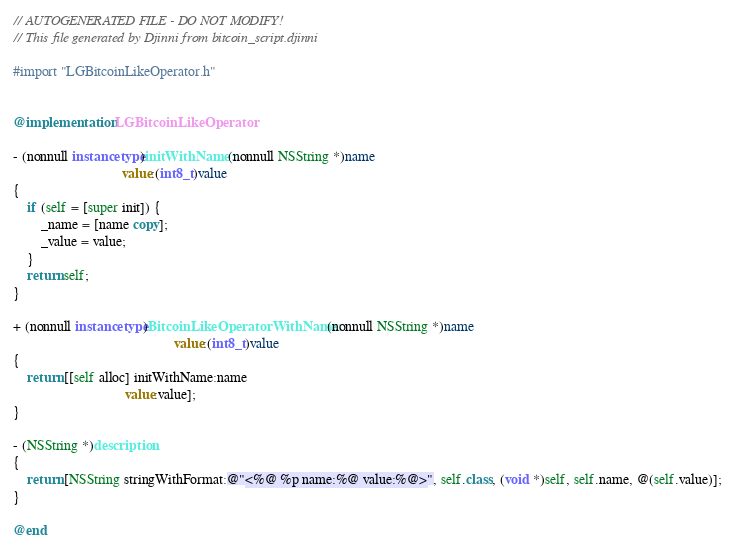<code> <loc_0><loc_0><loc_500><loc_500><_ObjectiveC_>// AUTOGENERATED FILE - DO NOT MODIFY!
// This file generated by Djinni from bitcoin_script.djinni

#import "LGBitcoinLikeOperator.h"


@implementation LGBitcoinLikeOperator

- (nonnull instancetype)initWithName:(nonnull NSString *)name
                               value:(int8_t)value
{
    if (self = [super init]) {
        _name = [name copy];
        _value = value;
    }
    return self;
}

+ (nonnull instancetype)BitcoinLikeOperatorWithName:(nonnull NSString *)name
                                              value:(int8_t)value
{
    return [[self alloc] initWithName:name
                                value:value];
}

- (NSString *)description
{
    return [NSString stringWithFormat:@"<%@ %p name:%@ value:%@>", self.class, (void *)self, self.name, @(self.value)];
}

@end
</code> 